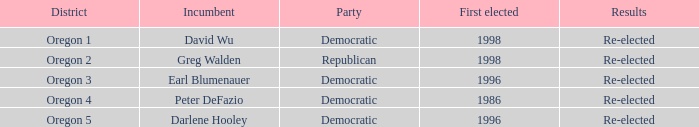Which district features a democratic incumbent whose first election win occurred before 1996? Oregon 4. 